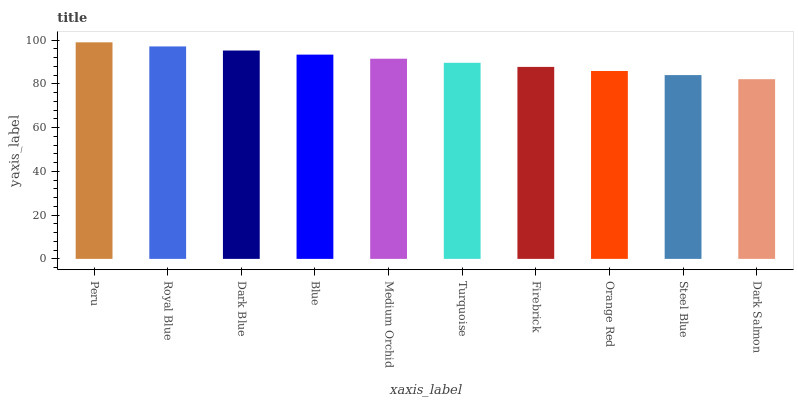Is Dark Salmon the minimum?
Answer yes or no. Yes. Is Peru the maximum?
Answer yes or no. Yes. Is Royal Blue the minimum?
Answer yes or no. No. Is Royal Blue the maximum?
Answer yes or no. No. Is Peru greater than Royal Blue?
Answer yes or no. Yes. Is Royal Blue less than Peru?
Answer yes or no. Yes. Is Royal Blue greater than Peru?
Answer yes or no. No. Is Peru less than Royal Blue?
Answer yes or no. No. Is Medium Orchid the high median?
Answer yes or no. Yes. Is Turquoise the low median?
Answer yes or no. Yes. Is Turquoise the high median?
Answer yes or no. No. Is Royal Blue the low median?
Answer yes or no. No. 